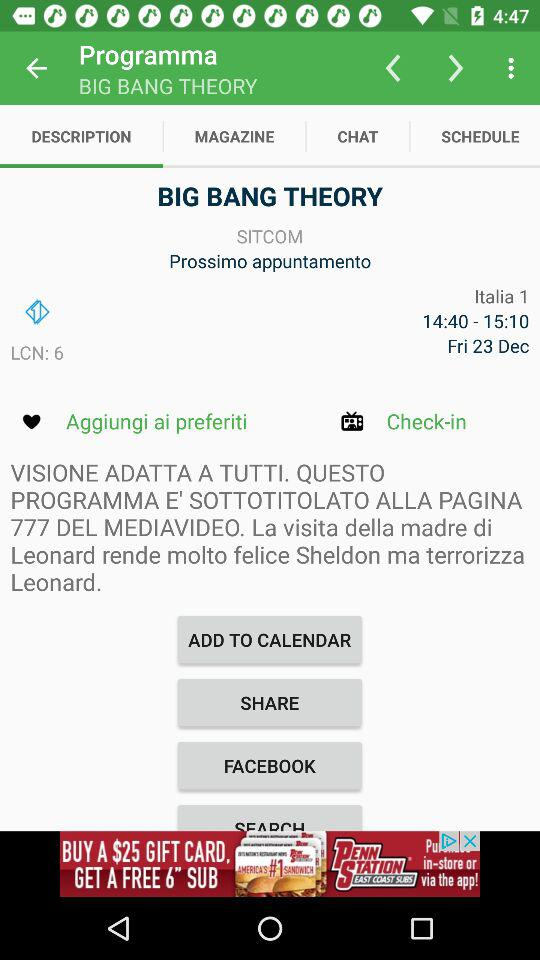What is the mentioned date? The mentioned date is Friday, December 23. 